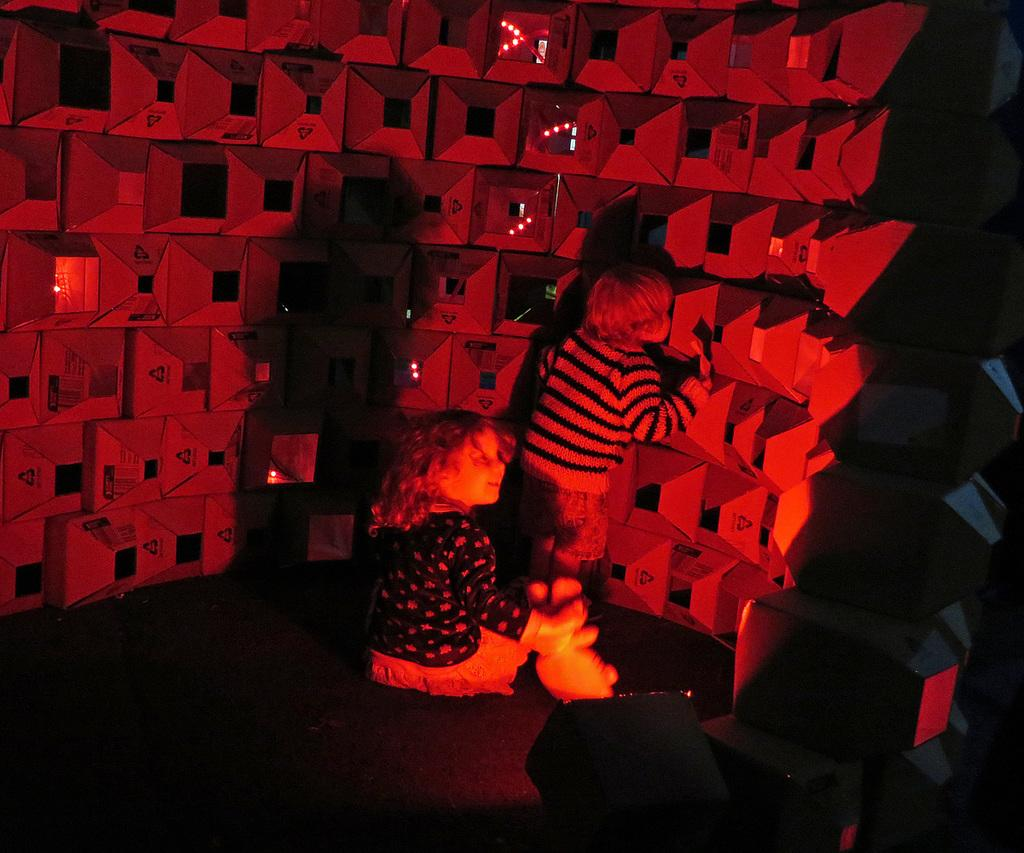How many children are present in the image? There are 2 children in the image. What can be seen at the front of the image? There is a light at the front of the image. Can you describe the background of the image? The background of the image is block-colored. What type of land division can be seen in the image? There is no land division present in the image; it features 2 children and a light at the front. 